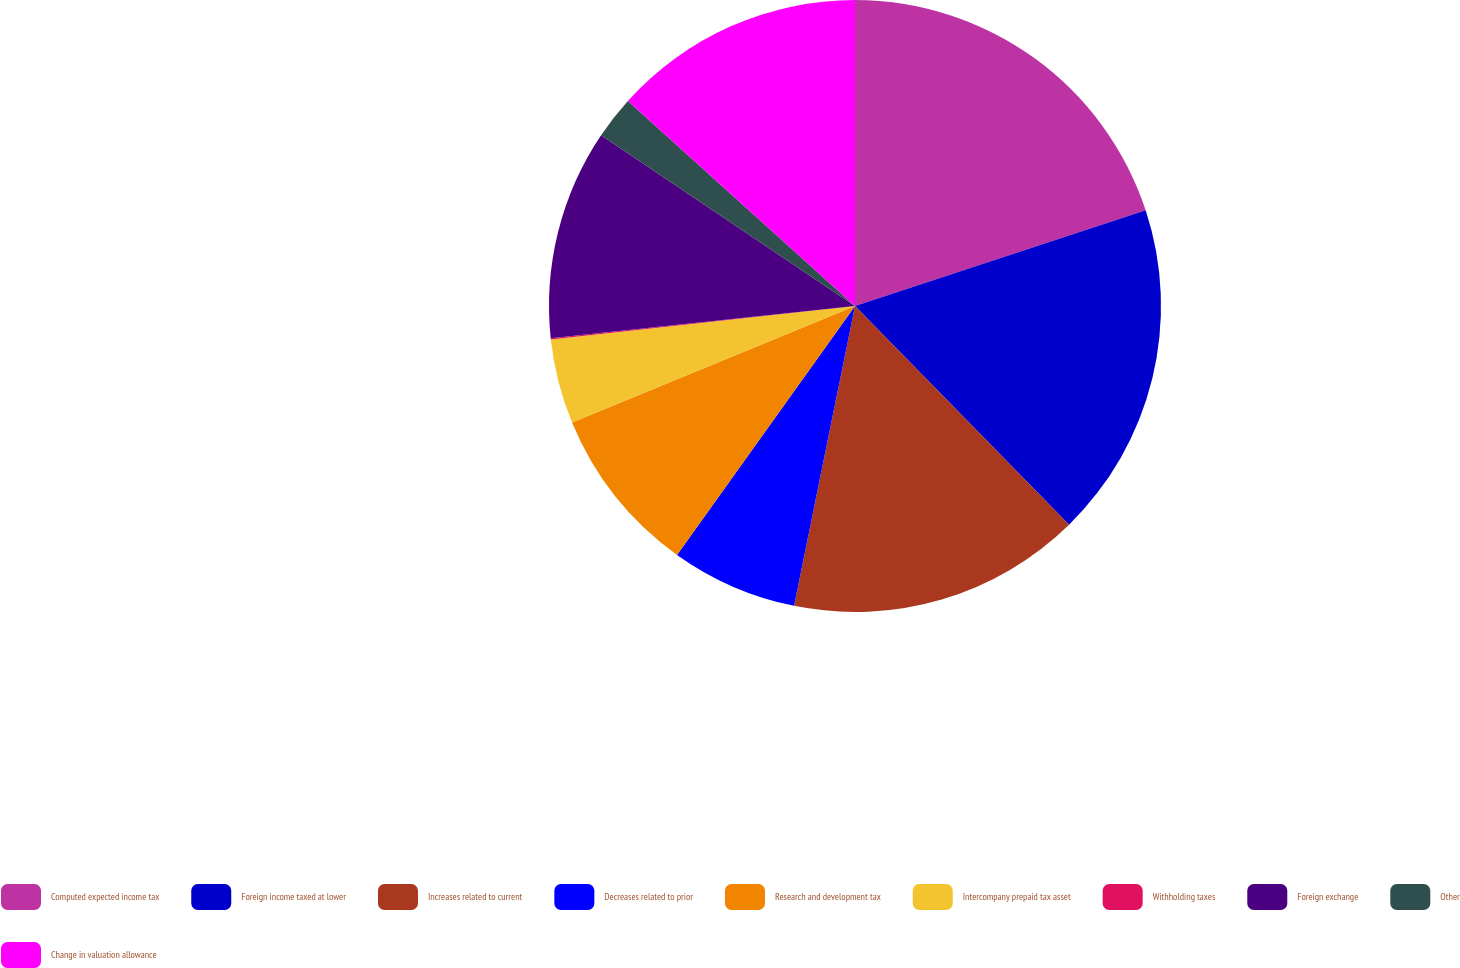Convert chart to OTSL. <chart><loc_0><loc_0><loc_500><loc_500><pie_chart><fcel>Computed expected income tax<fcel>Foreign income taxed at lower<fcel>Increases related to current<fcel>Decreases related to prior<fcel>Research and development tax<fcel>Intercompany prepaid tax asset<fcel>Withholding taxes<fcel>Foreign exchange<fcel>Other<fcel>Change in valuation allowance<nl><fcel>19.94%<fcel>17.73%<fcel>15.52%<fcel>6.69%<fcel>8.9%<fcel>4.48%<fcel>0.06%<fcel>11.1%<fcel>2.27%<fcel>13.31%<nl></chart> 